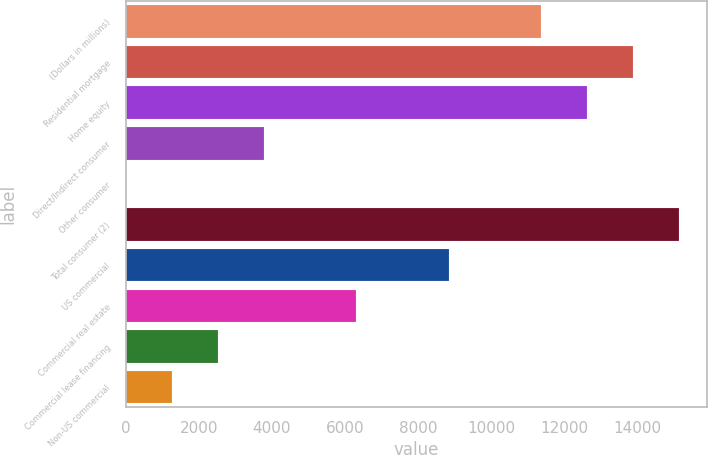<chart> <loc_0><loc_0><loc_500><loc_500><bar_chart><fcel>(Dollars in millions)<fcel>Residential mortgage<fcel>Home equity<fcel>Direct/Indirect consumer<fcel>Other consumer<fcel>Total consumer (2)<fcel>US commercial<fcel>Commercial real estate<fcel>Commercial lease financing<fcel>Non-US commercial<nl><fcel>11366.2<fcel>13891.8<fcel>12629<fcel>3789.4<fcel>1<fcel>15154.6<fcel>8840.6<fcel>6315<fcel>2526.6<fcel>1263.8<nl></chart> 